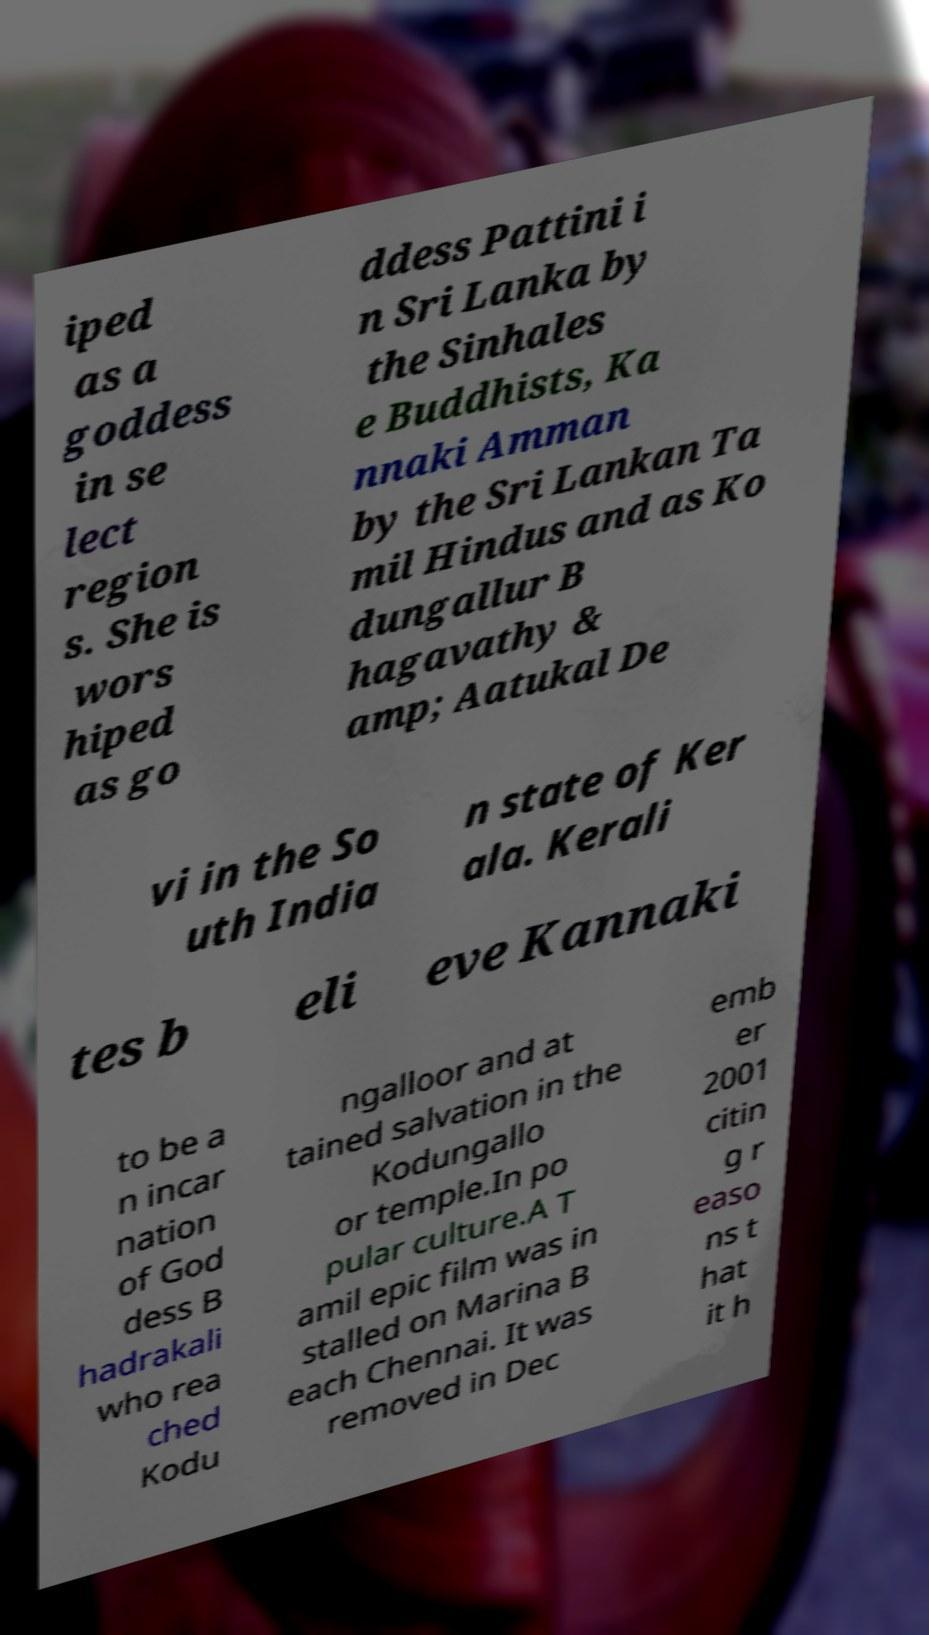Could you extract and type out the text from this image? iped as a goddess in se lect region s. She is wors hiped as go ddess Pattini i n Sri Lanka by the Sinhales e Buddhists, Ka nnaki Amman by the Sri Lankan Ta mil Hindus and as Ko dungallur B hagavathy & amp; Aatukal De vi in the So uth India n state of Ker ala. Kerali tes b eli eve Kannaki to be a n incar nation of God dess B hadrakali who rea ched Kodu ngalloor and at tained salvation in the Kodungallo or temple.In po pular culture.A T amil epic film was in stalled on Marina B each Chennai. It was removed in Dec emb er 2001 citin g r easo ns t hat it h 